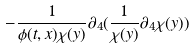<formula> <loc_0><loc_0><loc_500><loc_500>- \frac { 1 } { \phi ( t , x ) \chi ( y ) } \partial _ { 4 } ( \frac { 1 } { \chi ( y ) } \partial _ { 4 } \chi ( y ) )</formula> 